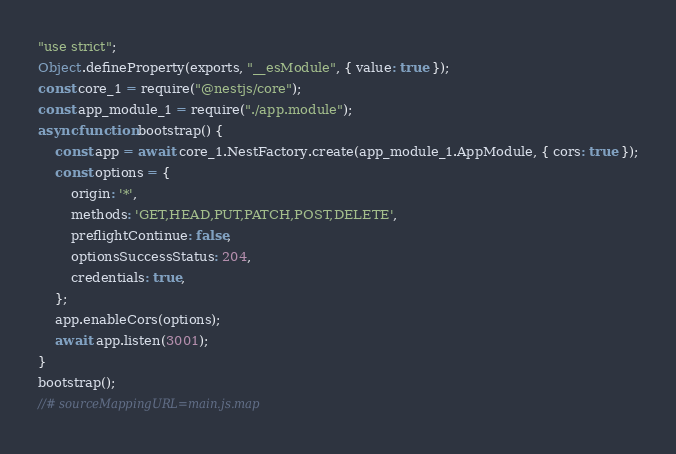<code> <loc_0><loc_0><loc_500><loc_500><_JavaScript_>"use strict";
Object.defineProperty(exports, "__esModule", { value: true });
const core_1 = require("@nestjs/core");
const app_module_1 = require("./app.module");
async function bootstrap() {
    const app = await core_1.NestFactory.create(app_module_1.AppModule, { cors: true });
    const options = {
        origin: '*',
        methods: 'GET,HEAD,PUT,PATCH,POST,DELETE',
        preflightContinue: false,
        optionsSuccessStatus: 204,
        credentials: true,
    };
    app.enableCors(options);
    await app.listen(3001);
}
bootstrap();
//# sourceMappingURL=main.js.map</code> 